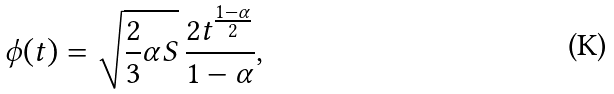Convert formula to latex. <formula><loc_0><loc_0><loc_500><loc_500>\phi ( t ) = \sqrt { \frac { 2 } { 3 } \alpha S } \, \frac { 2 t ^ { \frac { 1 - \alpha } { 2 } } } { 1 - \alpha } ,</formula> 